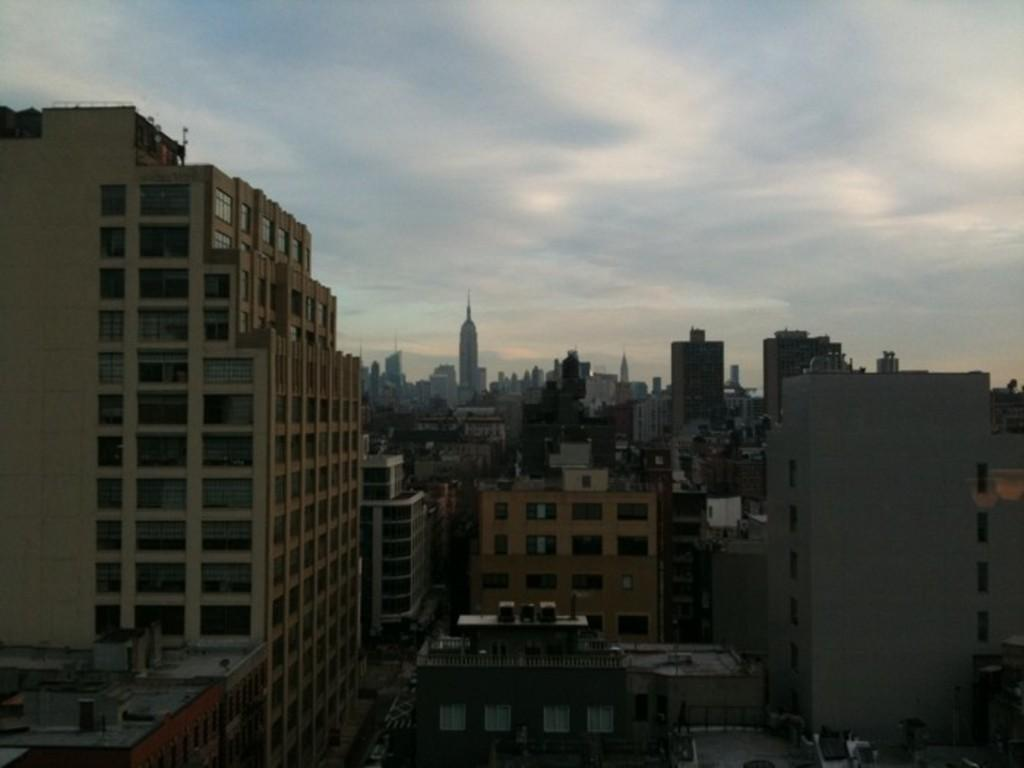What type of view is shown in the image? The image is an aerial view of a city. What structures can be seen in the image? There are buildings in the image. What is the condition of the sky in the image? The sky is cloudy in the image. Can you see any yaks grazing in the city in the image? There are no yaks present in the image; it shows an aerial view of a city with buildings and a cloudy sky. 